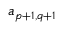Convert formula to latex. <formula><loc_0><loc_0><loc_500><loc_500>a _ { p + 1 , q + 1 }</formula> 